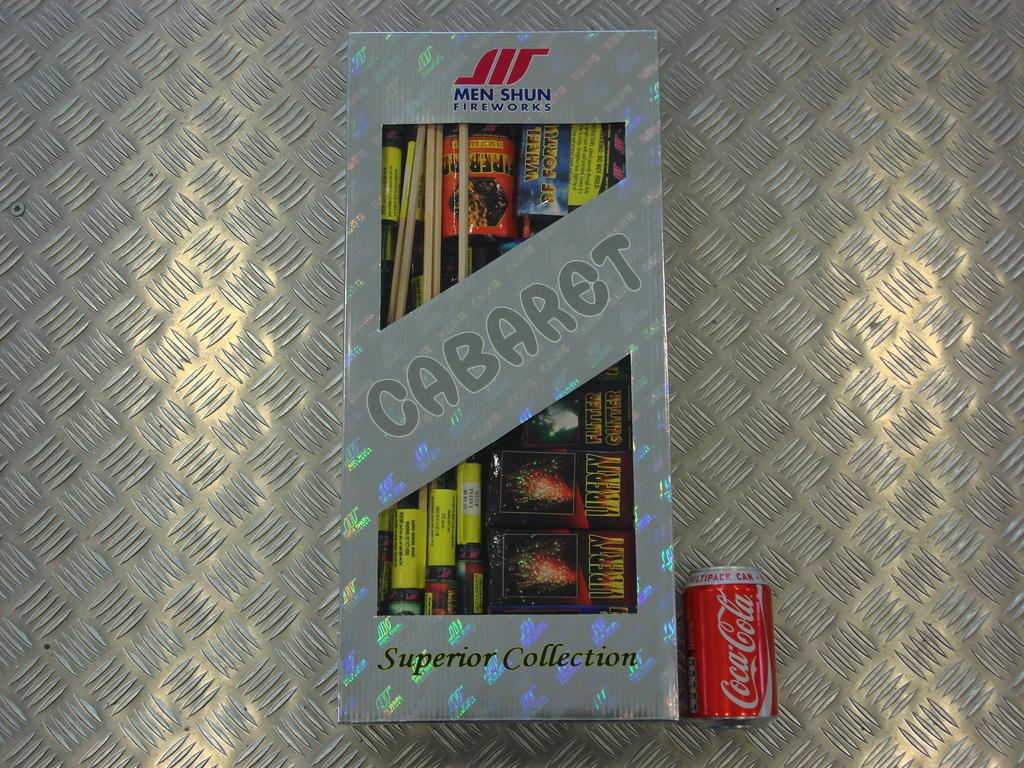Provide a one-sentence caption for the provided image. A box of brand new fireworks laying next to a coca cola can. 